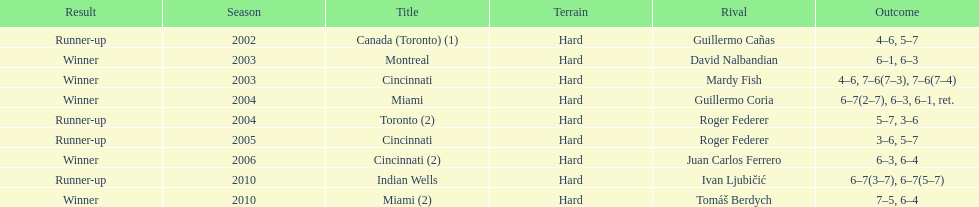What was the highest number of consecutive wins? 3. 